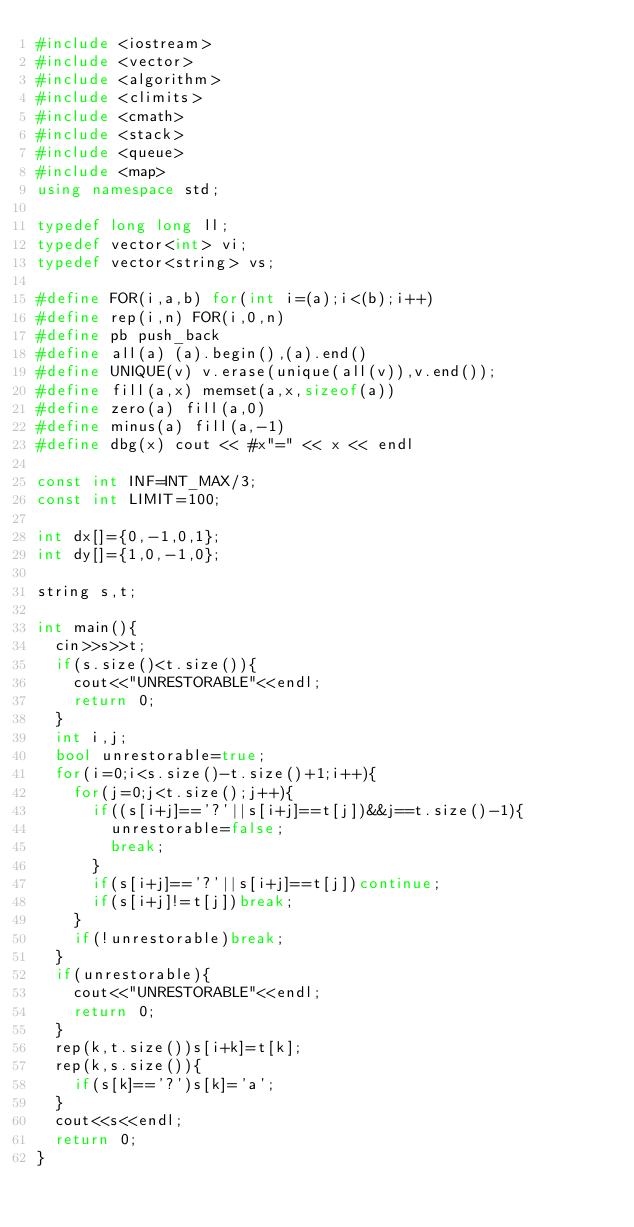Convert code to text. <code><loc_0><loc_0><loc_500><loc_500><_C++_>#include <iostream>
#include <vector>
#include <algorithm>
#include <climits>
#include <cmath>
#include <stack>
#include <queue>
#include <map>
using namespace std;

typedef long long ll;
typedef vector<int> vi;
typedef vector<string> vs;

#define FOR(i,a,b) for(int i=(a);i<(b);i++)
#define rep(i,n) FOR(i,0,n)
#define pb push_back
#define all(a) (a).begin(),(a).end()
#define UNIQUE(v) v.erase(unique(all(v)),v.end());
#define fill(a,x) memset(a,x,sizeof(a))
#define zero(a) fill(a,0)
#define minus(a) fill(a,-1)
#define dbg(x) cout << #x"=" << x << endl

const int INF=INT_MAX/3;
const int LIMIT=100;

int dx[]={0,-1,0,1};
int dy[]={1,0,-1,0};

string s,t;

int main(){
  cin>>s>>t;
  if(s.size()<t.size()){
    cout<<"UNRESTORABLE"<<endl;
    return 0;
  }
  int i,j;
  bool unrestorable=true;
  for(i=0;i<s.size()-t.size()+1;i++){
    for(j=0;j<t.size();j++){
      if((s[i+j]=='?'||s[i+j]==t[j])&&j==t.size()-1){
        unrestorable=false;
        break;
      }
      if(s[i+j]=='?'||s[i+j]==t[j])continue;
      if(s[i+j]!=t[j])break;
    }
    if(!unrestorable)break;
  }
  if(unrestorable){
    cout<<"UNRESTORABLE"<<endl;
    return 0;
  }
  rep(k,t.size())s[i+k]=t[k];
  rep(k,s.size()){
    if(s[k]=='?')s[k]='a';
  }
  cout<<s<<endl;
  return 0;
}</code> 